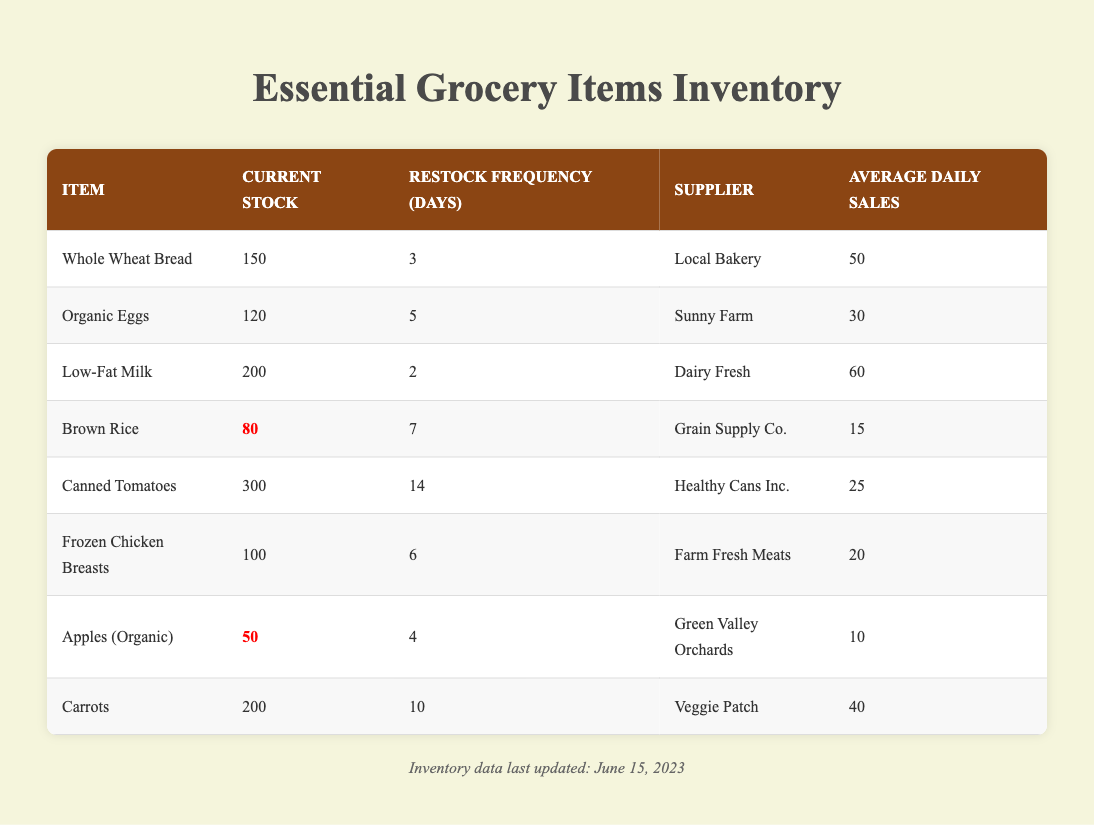What is the current stock of Low-Fat Milk? The table shows various items along with their current stock levels. For Low-Fat Milk, the entry indicates a current stock of 200.
Answer: 200 How often is Frozen Chicken Breasts restocked? The table provides restock frequencies for each item. Looking under Frozen Chicken Breasts, it is noted that they have a restock frequency of 6 days.
Answer: 6 days Is the stock level of Apples (Organic) below 60? We refer to the stock level for Apples (Organic), which is 50, confirming that it is indeed below 60. Therefore, the statement is true.
Answer: Yes What is the total current stock of all items? To find the total current stock, we sum up the stocks for all items: 150 + 120 + 200 + 80 + 300 + 100 + 50 + 200 = 1300.
Answer: 1300 Which item has the highest current stock? We check each current stock value and find that Canned Tomatoes has the highest stock at 300, compared to others.
Answer: Canned Tomatoes How many items have a restock frequency of less than 6 days? We analyze the restock frequencies: Low-Fat Milk (2), Whole Wheat Bread (3), and Frozen Chicken Breasts (6). The only items with frequencies less than 6 days are Low-Fat Milk and Whole Wheat Bread, totaling 2 items.
Answer: 2 items Does Brown Rice have a current stock that is sufficient to last for more than 5 days given its average daily sales? For Brown Rice, the current stock is 80, and the average daily sales are 15. To assess sufficiency over 5 days, we calculate 5 * 15 = 75. Since 80 is greater than 75, the stock is indeed sufficient.
Answer: Yes What is the average daily sales for items with less than 100 current stock? The items with less than 100 current stock are Apples (Organic) with an average daily sales of 10 and Frozen Chicken Breasts with 20. Therefore, we calculate the average: (10 + 20) / 2 = 15.
Answer: 15 How many suppliers provide restock for items that sell more than 25 units daily? Filtering through the items, Low-Fat Milk (60), Whole Wheat Bread (50), and Carrots (40) all exceed 25 units of average daily sales. The unique suppliers for these items are Dairy Fresh, Local Bakery, and Veggie Patch, totaling 3 suppliers.
Answer: 3 suppliers 